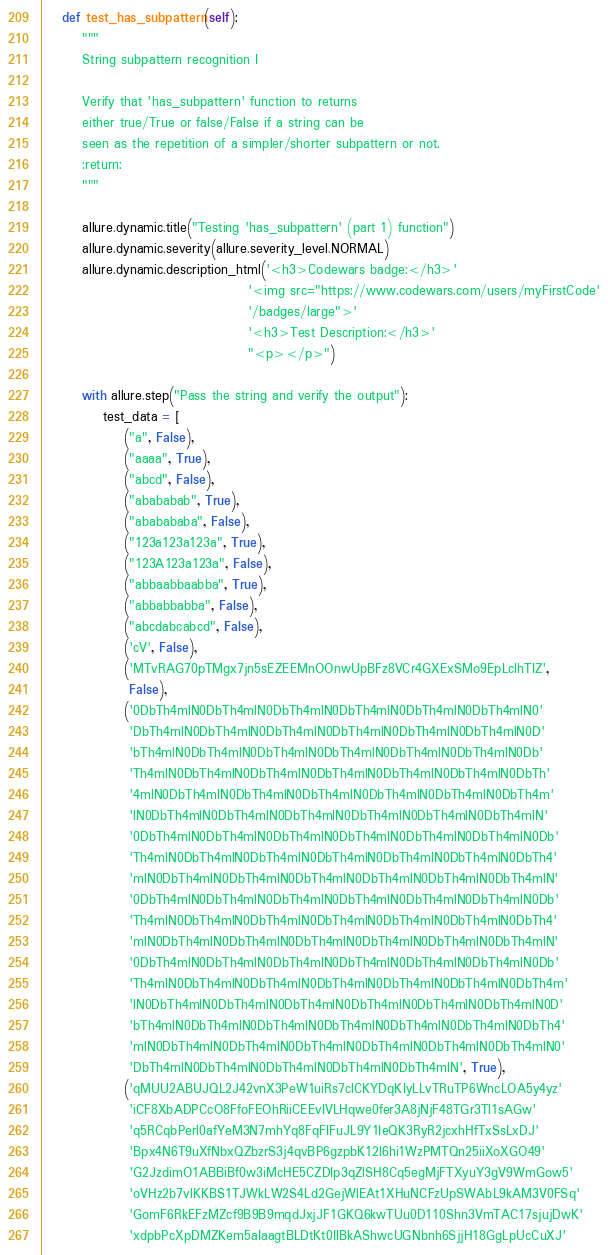<code> <loc_0><loc_0><loc_500><loc_500><_Python_>
    def test_has_subpattern(self):
        """
        String subpattern recognition I

        Verify that 'has_subpattern' function to returns
        either true/True or false/False if a string can be
        seen as the repetition of a simpler/shorter subpattern or not.
        :return:
        """

        allure.dynamic.title("Testing 'has_subpattern' (part 1) function")
        allure.dynamic.severity(allure.severity_level.NORMAL)
        allure.dynamic.description_html('<h3>Codewars badge:</h3>'
                                        '<img src="https://www.codewars.com/users/myFirstCode'
                                        '/badges/large">'
                                        '<h3>Test Description:</h3>'
                                        "<p></p>")

        with allure.step("Pass the string and verify the output"):
            test_data = [
                ("a", False),
                ("aaaa", True),
                ("abcd", False),
                ("abababab", True),
                ("ababababa", False),
                ("123a123a123a", True),
                ("123A123a123a", False),
                ("abbaabbaabba", True),
                ("abbabbabba", False),
                ("abcdabcabcd", False),
                ('cV', False),
                ('MTvRAG70pTMgx7jn5sEZEEMnOOnwUpBFz8VCr4GXExSMo9EpLclhTIZ',
                 False),
                ('0DbTh4mlN0DbTh4mlN0DbTh4mlN0DbTh4mlN0DbTh4mlN0DbTh4mlN0'
                 'DbTh4mlN0DbTh4mlN0DbTh4mlN0DbTh4mlN0DbTh4mlN0DbTh4mlN0D'
                 'bTh4mlN0DbTh4mlN0DbTh4mlN0DbTh4mlN0DbTh4mlN0DbTh4mlN0Db'
                 'Th4mlN0DbTh4mlN0DbTh4mlN0DbTh4mlN0DbTh4mlN0DbTh4mlN0DbTh'
                 '4mlN0DbTh4mlN0DbTh4mlN0DbTh4mlN0DbTh4mlN0DbTh4mlN0DbTh4m'
                 'lN0DbTh4mlN0DbTh4mlN0DbTh4mlN0DbTh4mlN0DbTh4mlN0DbTh4mlN'
                 '0DbTh4mlN0DbTh4mlN0DbTh4mlN0DbTh4mlN0DbTh4mlN0DbTh4mlN0Db'
                 'Th4mlN0DbTh4mlN0DbTh4mlN0DbTh4mlN0DbTh4mlN0DbTh4mlN0DbTh4'
                 'mlN0DbTh4mlN0DbTh4mlN0DbTh4mlN0DbTh4mlN0DbTh4mlN0DbTh4mlN'
                 '0DbTh4mlN0DbTh4mlN0DbTh4mlN0DbTh4mlN0DbTh4mlN0DbTh4mlN0Db'
                 'Th4mlN0DbTh4mlN0DbTh4mlN0DbTh4mlN0DbTh4mlN0DbTh4mlN0DbTh4'
                 'mlN0DbTh4mlN0DbTh4mlN0DbTh4mlN0DbTh4mlN0DbTh4mlN0DbTh4mlN'
                 '0DbTh4mlN0DbTh4mlN0DbTh4mlN0DbTh4mlN0DbTh4mlN0DbTh4mlN0Db'
                 'Th4mlN0DbTh4mlN0DbTh4mlN0DbTh4mlN0DbTh4mlN0DbTh4mlN0DbTh4m'
                 'lN0DbTh4mlN0DbTh4mlN0DbTh4mlN0DbTh4mlN0DbTh4mlN0DbTh4mlN0D'
                 'bTh4mlN0DbTh4mlN0DbTh4mlN0DbTh4mlN0DbTh4mlN0DbTh4mlN0DbTh4'
                 'mlN0DbTh4mlN0DbTh4mlN0DbTh4mlN0DbTh4mlN0DbTh4mlN0DbTh4mlN0'
                 'DbTh4mlN0DbTh4mlN0DbTh4mlN0DbTh4mlN0DbTh4mlN', True),
                ('qMUU2ABUJQL2J42vnX3PeW1uiRs7clCKYDqKIyLLvTRuTP6WncLOA5y4yz'
                 'iCF8XbADPCcO8FfoFEOhRiiCEEvIVLHqwe0fer3A8jNjF48TGr3Tl1sAGw'
                 'q5RCqbPerl0afYeM3N7mhYq8FqFIFuJL9Y1IeQK3RyR2jcxhHfTxSsLxDJ'
                 'Bpx4N6T9uXfNbxQZbzrS3j4qvBP6gzpbK12l6hi1WzPMTQn25iiXoXGO49'
                 'G2JzdimO1ABBiBf0w3iMcHE5CZDIp3qZlSH8Cq5egMjFTXyuY3gV9WmGow5'
                 'oVHz2b7vlKKBS1TJWkLW2S4Ld2GejWlEAt1XHuNCFzUpSWAbL9kAM3V0FSq'
                 'GomF6RkEFzMZcf9B9B9mqdJxjJF1GKQ6kwTUu0D110Shn3VmTAC17sjujDwK'
                 'xdpbPcXpDMZKem5aIaagtBLDtKt0IIBkAShwcUGNbnh6SjjH18GgLpUcCuXJ'</code> 